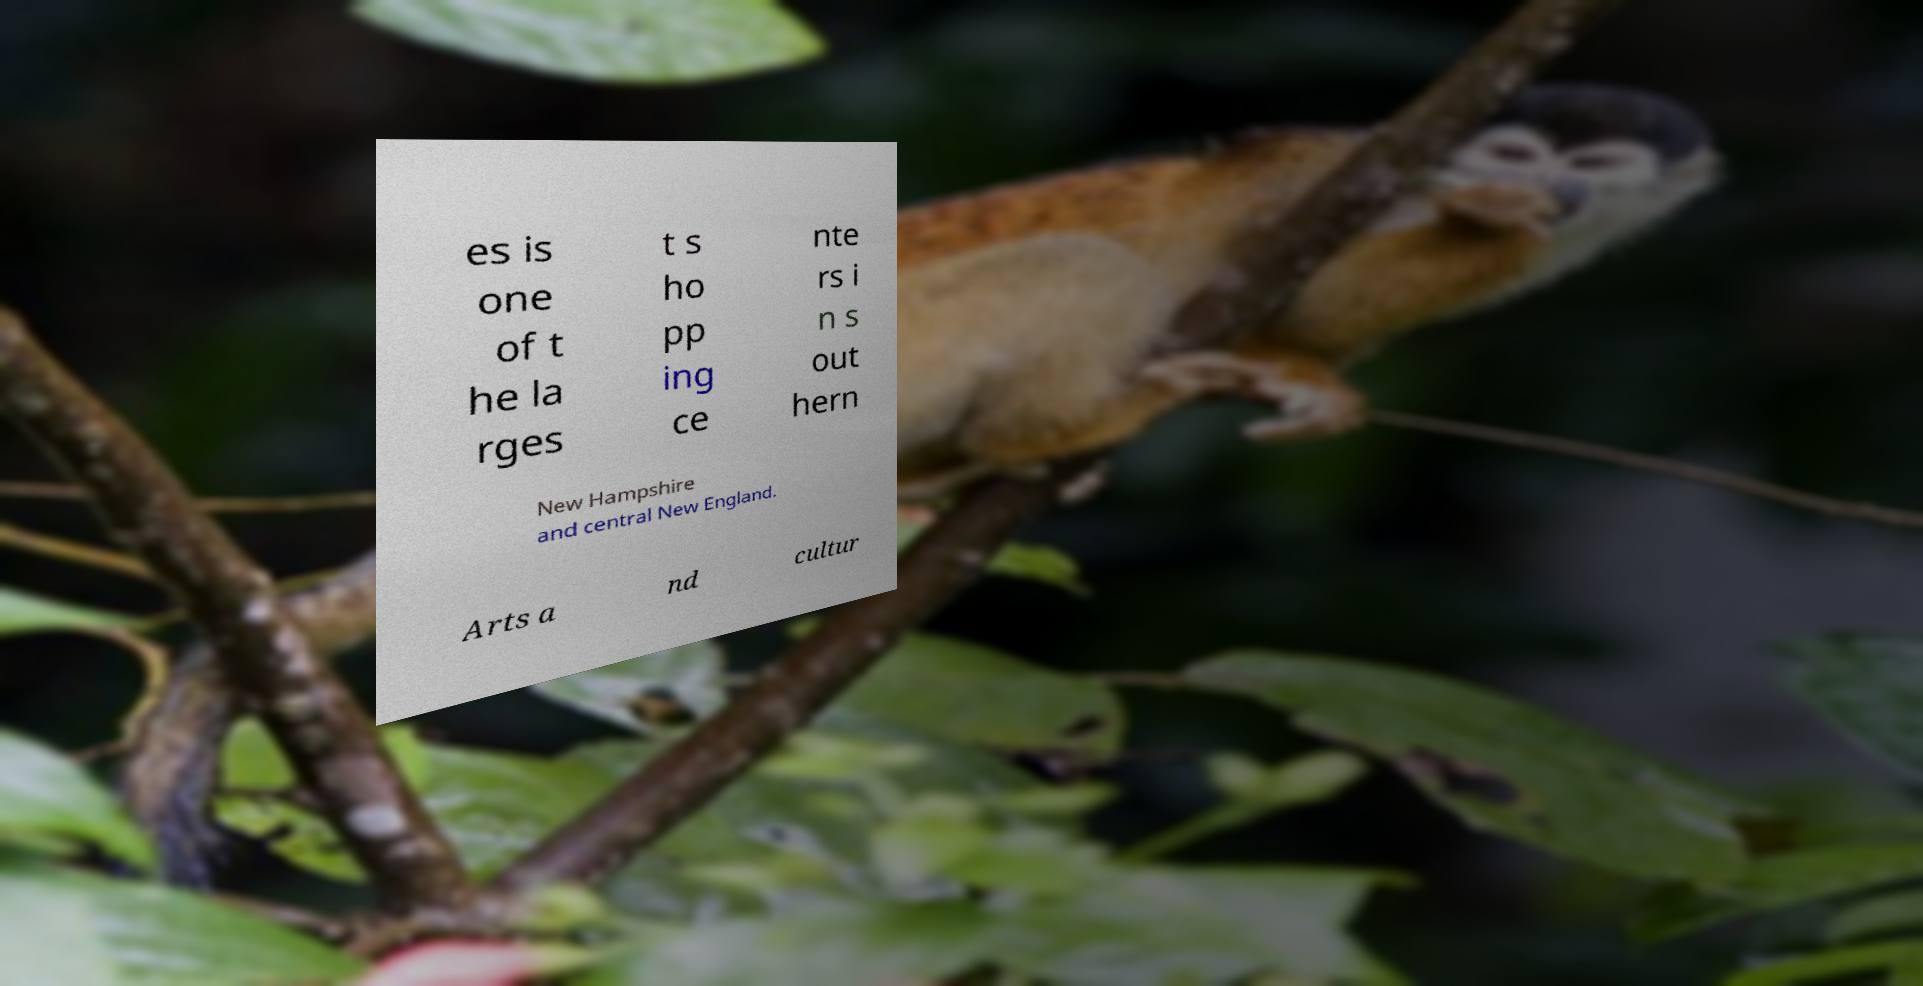Can you read and provide the text displayed in the image?This photo seems to have some interesting text. Can you extract and type it out for me? es is one of t he la rges t s ho pp ing ce nte rs i n s out hern New Hampshire and central New England. Arts a nd cultur 